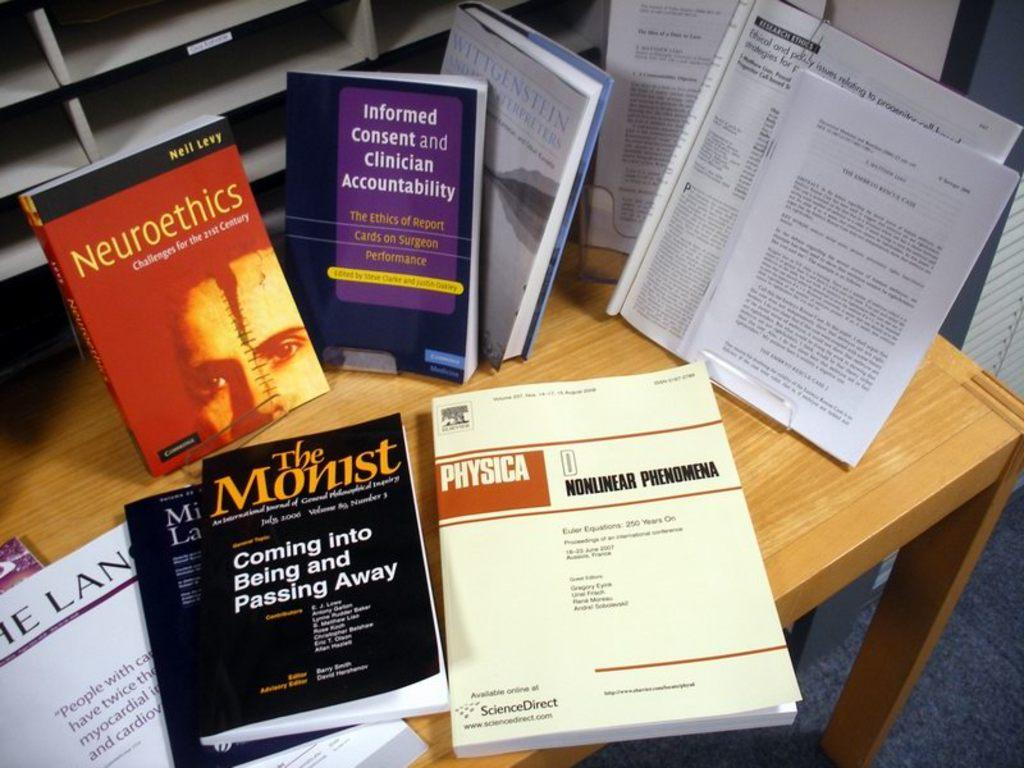<image>
Describe the image concisely. Various medical books are spread across a desk with one saying it is about neuroethics 